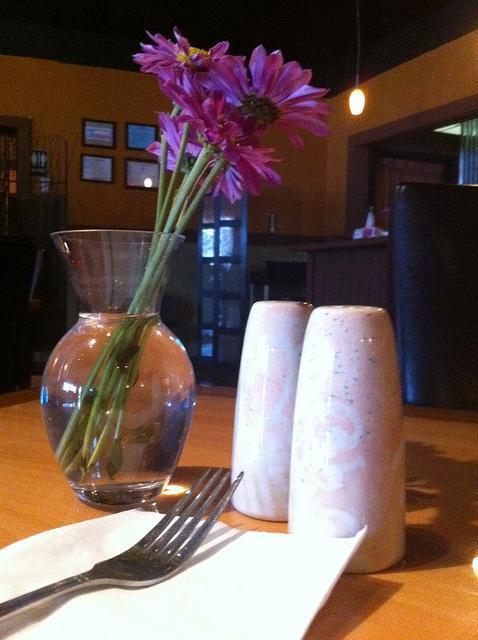How many forks are there?
Give a very brief answer. 1. 